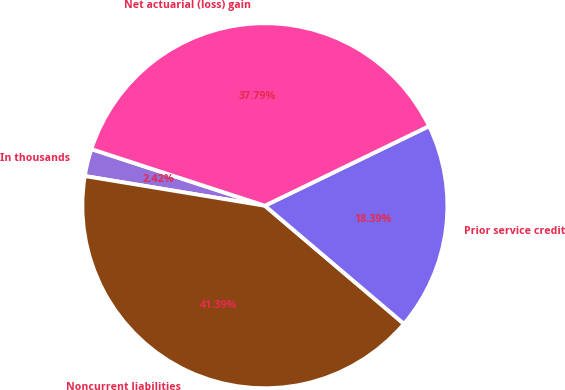Convert chart to OTSL. <chart><loc_0><loc_0><loc_500><loc_500><pie_chart><fcel>In thousands<fcel>Noncurrent liabilities<fcel>Prior service credit<fcel>Net actuarial (loss) gain<nl><fcel>2.42%<fcel>41.39%<fcel>18.39%<fcel>37.79%<nl></chart> 